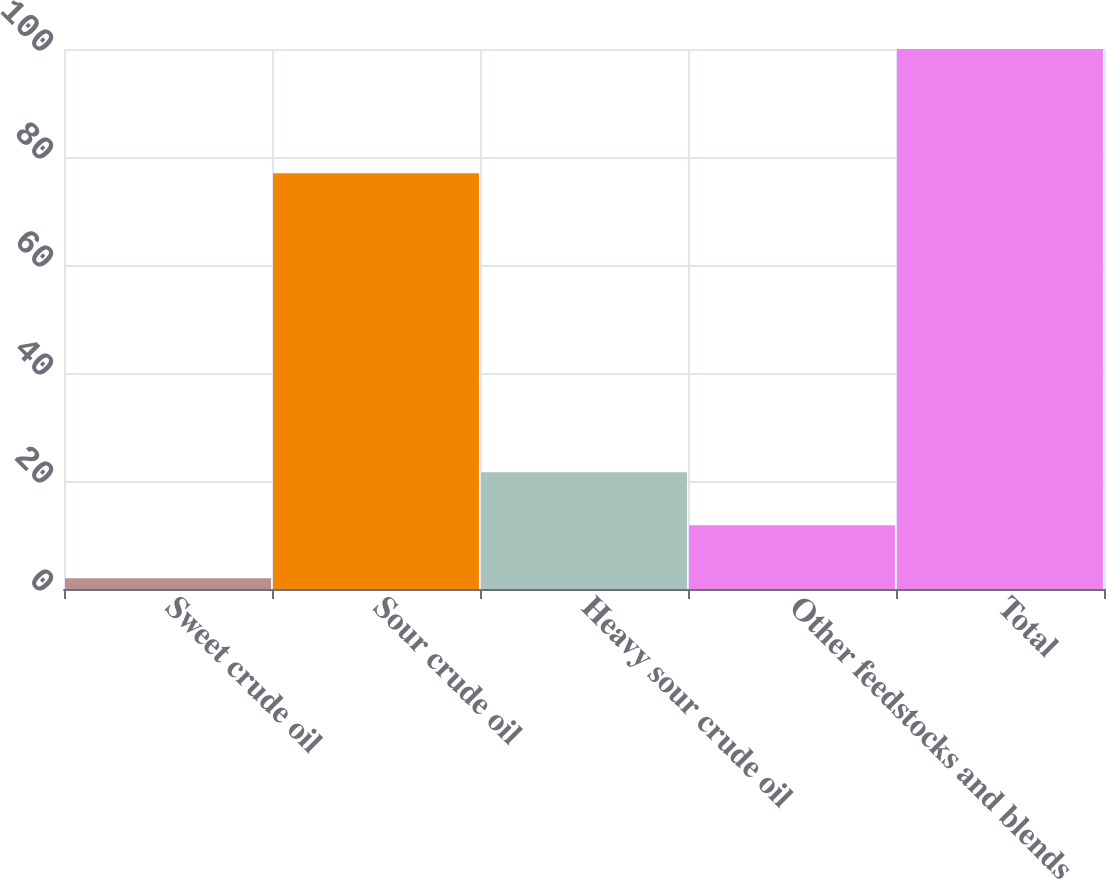Convert chart. <chart><loc_0><loc_0><loc_500><loc_500><bar_chart><fcel>Sweet crude oil<fcel>Sour crude oil<fcel>Heavy sour crude oil<fcel>Other feedstocks and blends<fcel>Total<nl><fcel>2<fcel>77<fcel>21.6<fcel>11.8<fcel>100<nl></chart> 